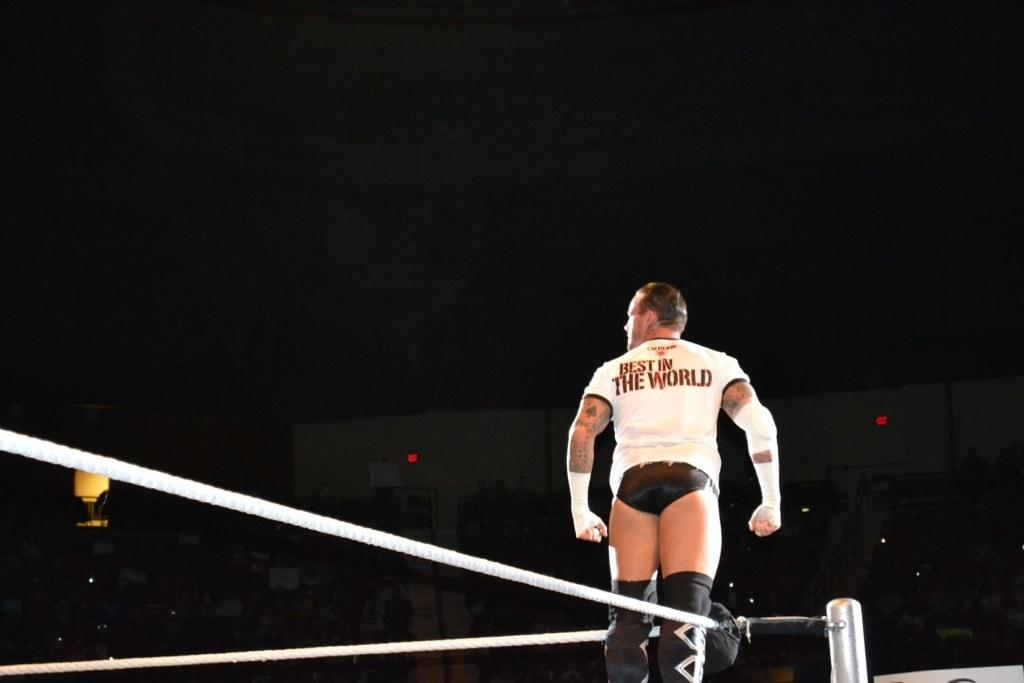<image>
Provide a brief description of the given image. a wrestler with a shirt that says Best n the World on the back of it. 